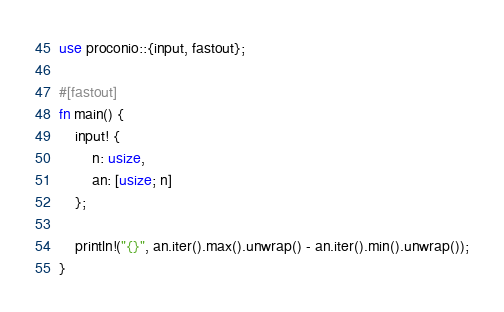Convert code to text. <code><loc_0><loc_0><loc_500><loc_500><_Rust_>use proconio::{input, fastout};

#[fastout]
fn main() {
    input! {
        n: usize,
        an: [usize; n]
    };

    println!("{}", an.iter().max().unwrap() - an.iter().min().unwrap());
}
</code> 